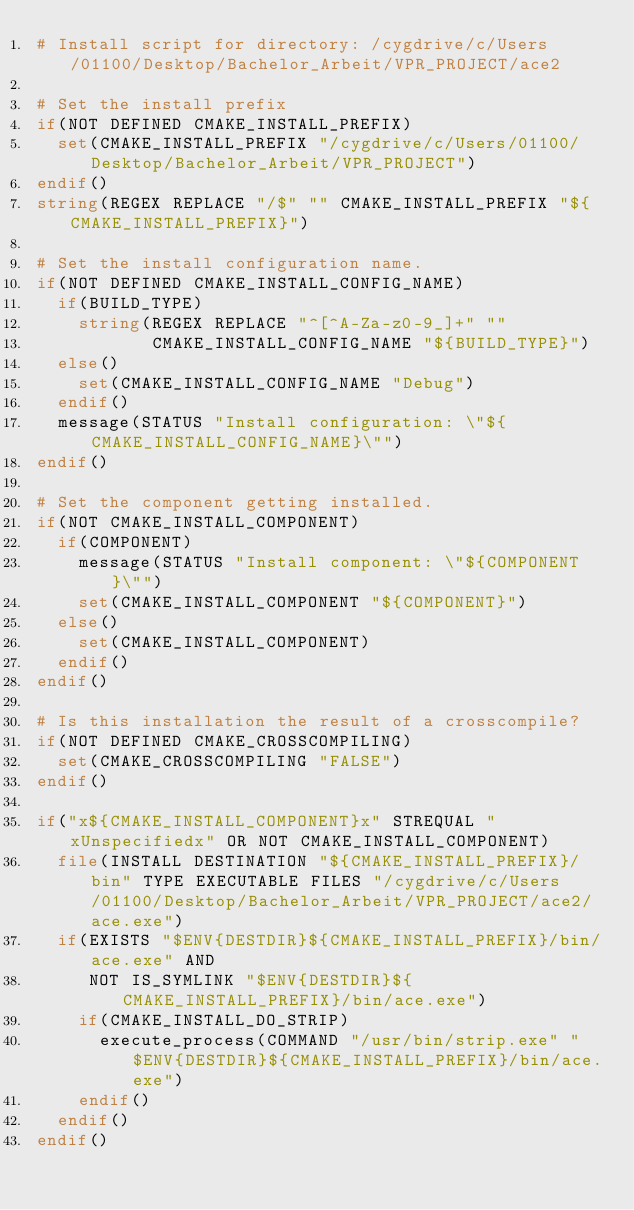<code> <loc_0><loc_0><loc_500><loc_500><_CMake_># Install script for directory: /cygdrive/c/Users/01100/Desktop/Bachelor_Arbeit/VPR_PROJECT/ace2

# Set the install prefix
if(NOT DEFINED CMAKE_INSTALL_PREFIX)
  set(CMAKE_INSTALL_PREFIX "/cygdrive/c/Users/01100/Desktop/Bachelor_Arbeit/VPR_PROJECT")
endif()
string(REGEX REPLACE "/$" "" CMAKE_INSTALL_PREFIX "${CMAKE_INSTALL_PREFIX}")

# Set the install configuration name.
if(NOT DEFINED CMAKE_INSTALL_CONFIG_NAME)
  if(BUILD_TYPE)
    string(REGEX REPLACE "^[^A-Za-z0-9_]+" ""
           CMAKE_INSTALL_CONFIG_NAME "${BUILD_TYPE}")
  else()
    set(CMAKE_INSTALL_CONFIG_NAME "Debug")
  endif()
  message(STATUS "Install configuration: \"${CMAKE_INSTALL_CONFIG_NAME}\"")
endif()

# Set the component getting installed.
if(NOT CMAKE_INSTALL_COMPONENT)
  if(COMPONENT)
    message(STATUS "Install component: \"${COMPONENT}\"")
    set(CMAKE_INSTALL_COMPONENT "${COMPONENT}")
  else()
    set(CMAKE_INSTALL_COMPONENT)
  endif()
endif()

# Is this installation the result of a crosscompile?
if(NOT DEFINED CMAKE_CROSSCOMPILING)
  set(CMAKE_CROSSCOMPILING "FALSE")
endif()

if("x${CMAKE_INSTALL_COMPONENT}x" STREQUAL "xUnspecifiedx" OR NOT CMAKE_INSTALL_COMPONENT)
  file(INSTALL DESTINATION "${CMAKE_INSTALL_PREFIX}/bin" TYPE EXECUTABLE FILES "/cygdrive/c/Users/01100/Desktop/Bachelor_Arbeit/VPR_PROJECT/ace2/ace.exe")
  if(EXISTS "$ENV{DESTDIR}${CMAKE_INSTALL_PREFIX}/bin/ace.exe" AND
     NOT IS_SYMLINK "$ENV{DESTDIR}${CMAKE_INSTALL_PREFIX}/bin/ace.exe")
    if(CMAKE_INSTALL_DO_STRIP)
      execute_process(COMMAND "/usr/bin/strip.exe" "$ENV{DESTDIR}${CMAKE_INSTALL_PREFIX}/bin/ace.exe")
    endif()
  endif()
endif()

</code> 